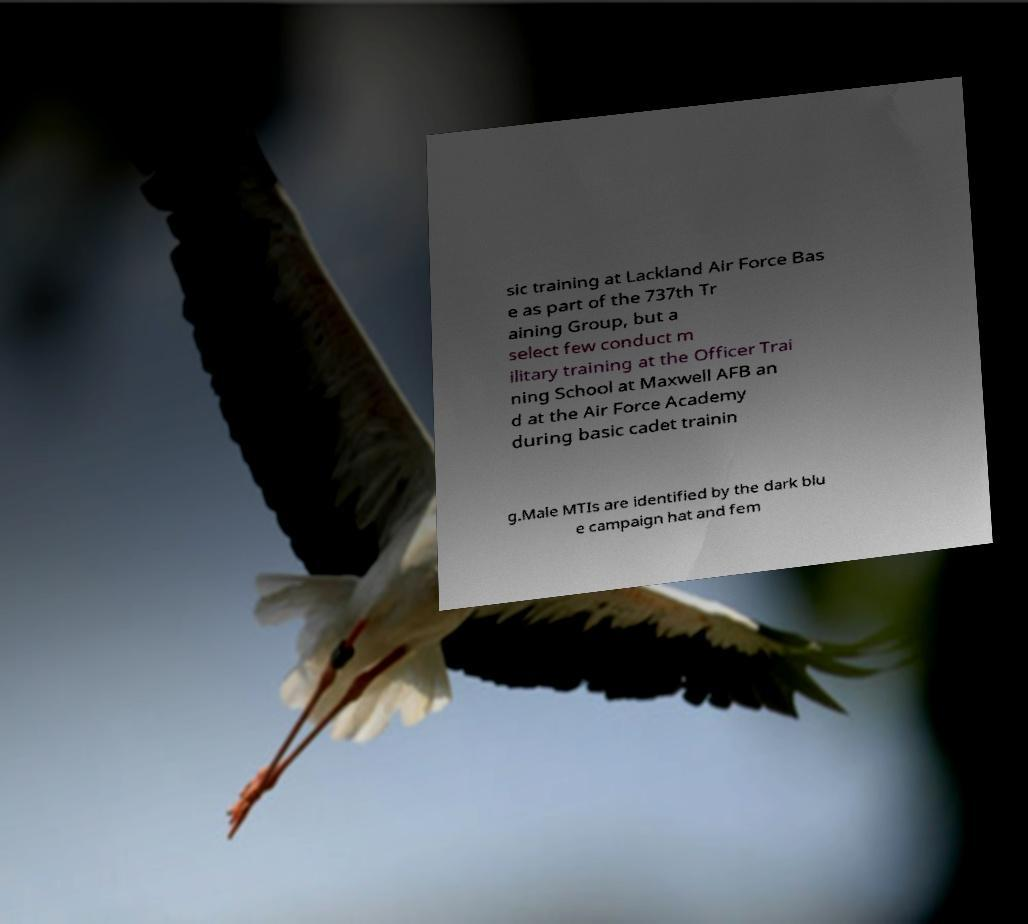I need the written content from this picture converted into text. Can you do that? sic training at Lackland Air Force Bas e as part of the 737th Tr aining Group, but a select few conduct m ilitary training at the Officer Trai ning School at Maxwell AFB an d at the Air Force Academy during basic cadet trainin g.Male MTIs are identified by the dark blu e campaign hat and fem 